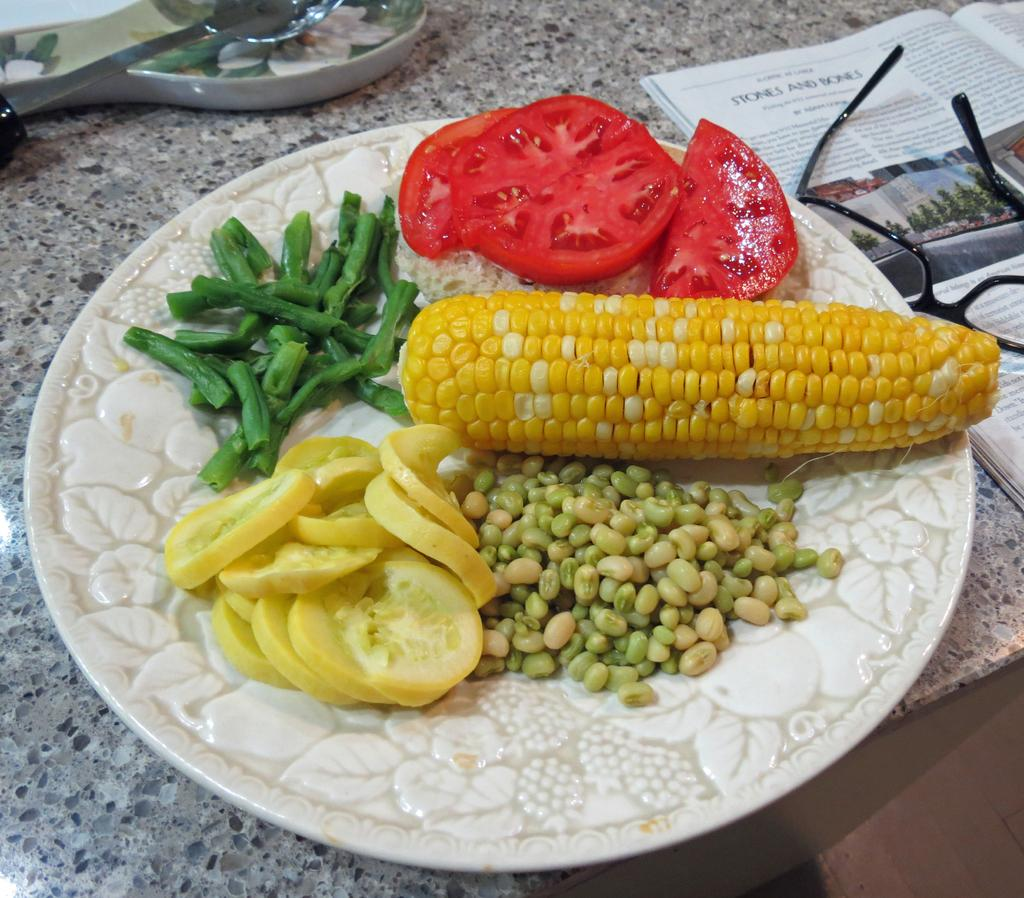What type of vegetables can be seen in the image? There is corn, beans, cucumber, and tomato slices in the image. How are the vegetables arranged in the image? The vegetables are on a plate in the image. Where is the plate located? The plate is on a kitchen platform in the image. What else can be seen in the image besides the vegetables? There is a newspaper, glasses, and a spoon in the image. What is the best tax-saving route for the vegetables in the image? There is no mention of taxes or routes in the image, as it features vegetables, a plate, a kitchen platform, a newspaper, glasses, and a spoon. 